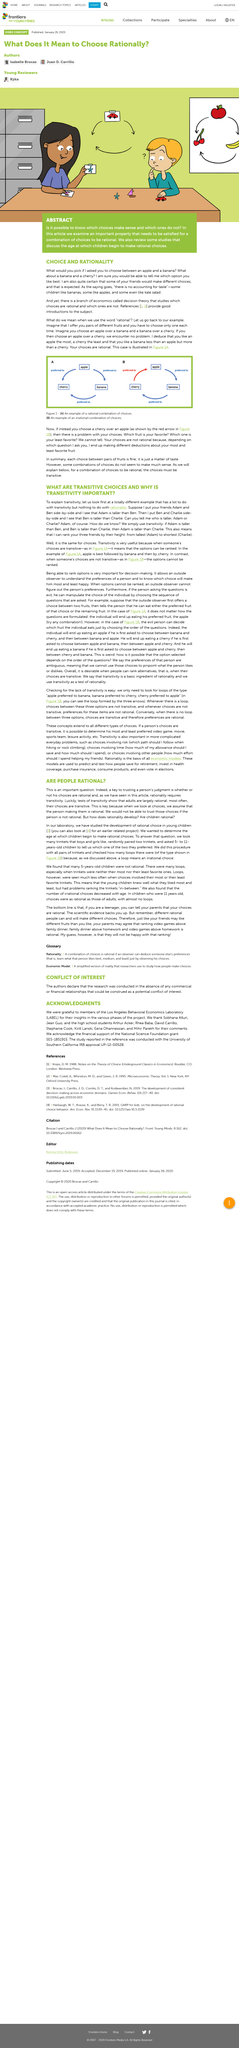Identify some key points in this picture. The University of Southern California conducted the study. The following individuals were acknowledged in this article: Sobhana Atluri, Jean Guo, Arthur Acker, Rhea Baba, David Carillo, Stephanie Cook, Kirill Lanski, Eena Ohannessian, and Mihir Parekh. The title of the article is 'ARE PEOPLE RATIONAL?' The acronym LABEL stands for "Los Angeles Behavioral Economics Laboratory. Yes, there is a branch of economics known as decision theory. 